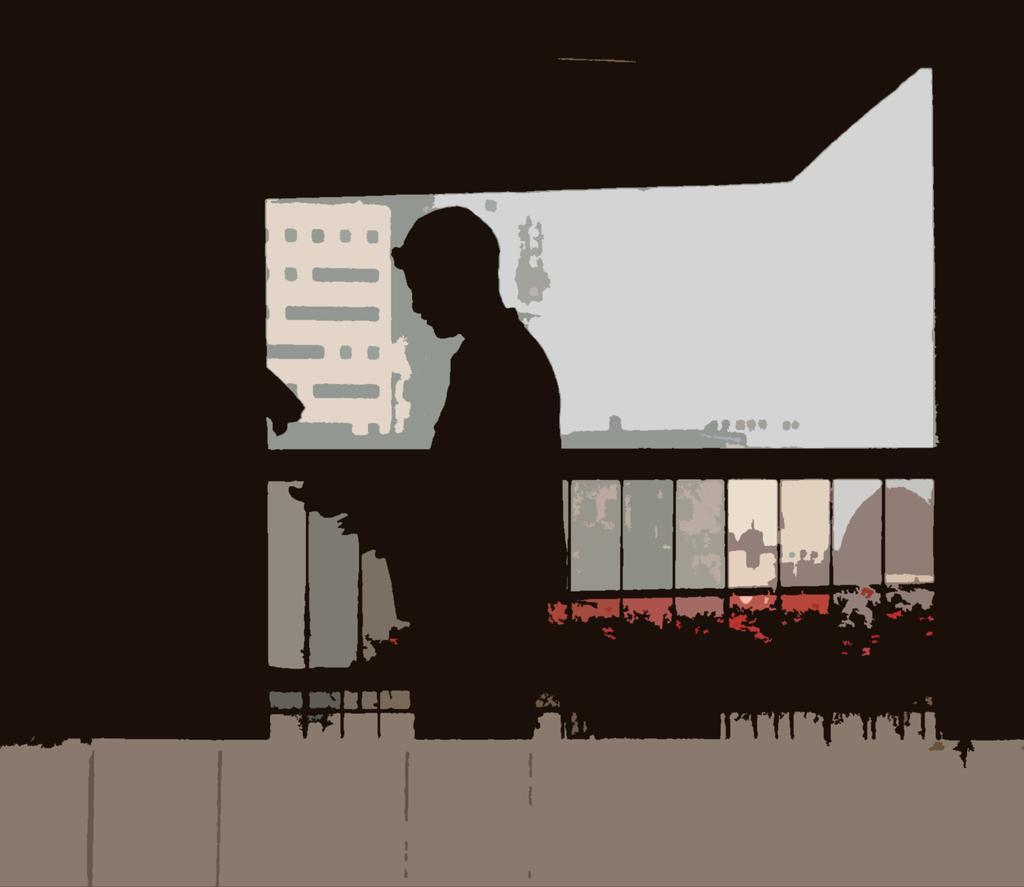Describe this image in one or two sentences. In this image there is a painting in which there is a person standing in the center and in the background there are buildings, there is a fence and there are plants. 